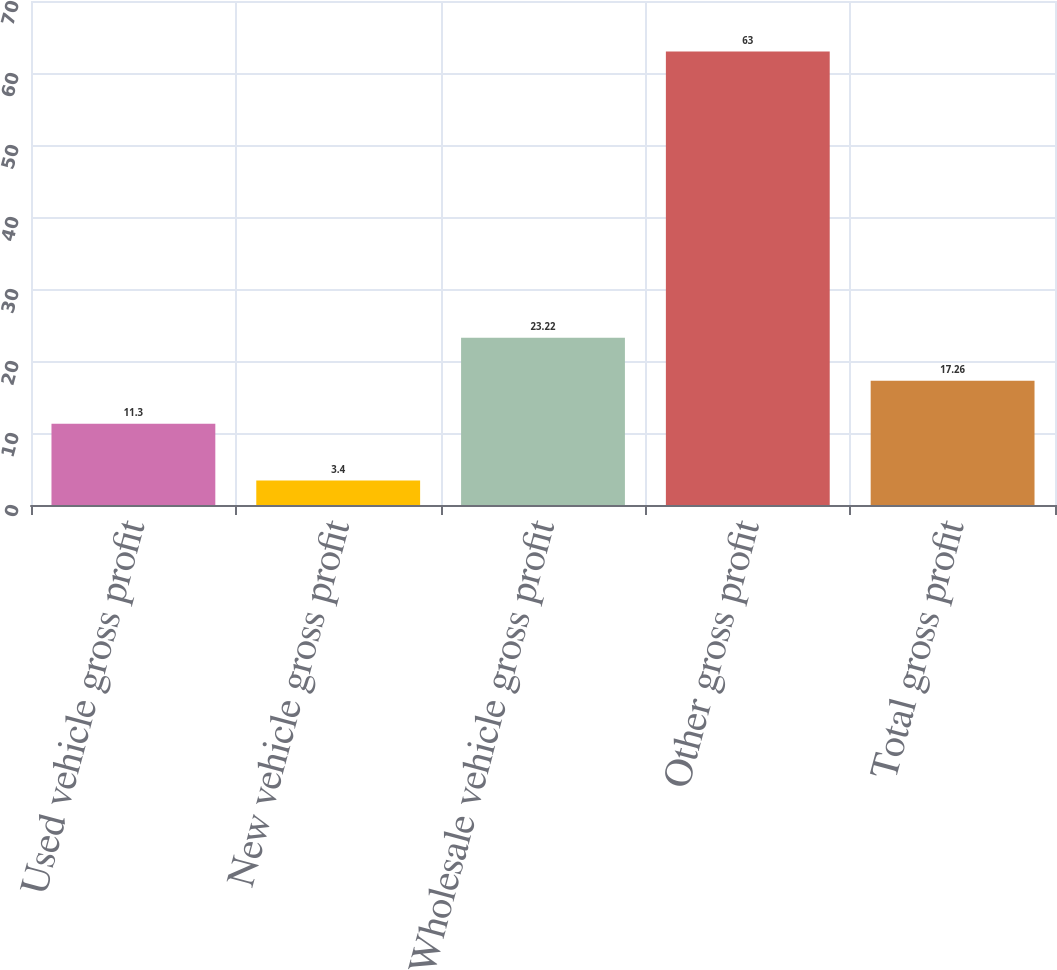Convert chart. <chart><loc_0><loc_0><loc_500><loc_500><bar_chart><fcel>Used vehicle gross profit<fcel>New vehicle gross profit<fcel>Wholesale vehicle gross profit<fcel>Other gross profit<fcel>Total gross profit<nl><fcel>11.3<fcel>3.4<fcel>23.22<fcel>63<fcel>17.26<nl></chart> 